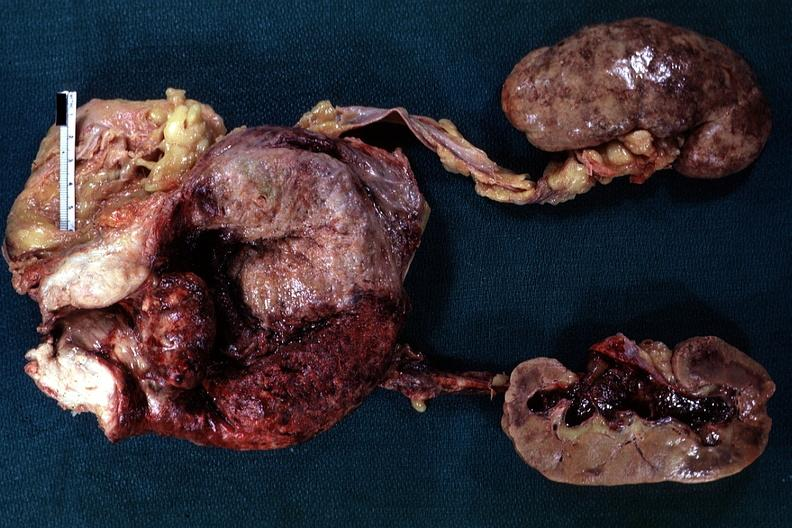does this image show large median bar type lesion with severe cystitis?
Answer the question using a single word or phrase. Yes 